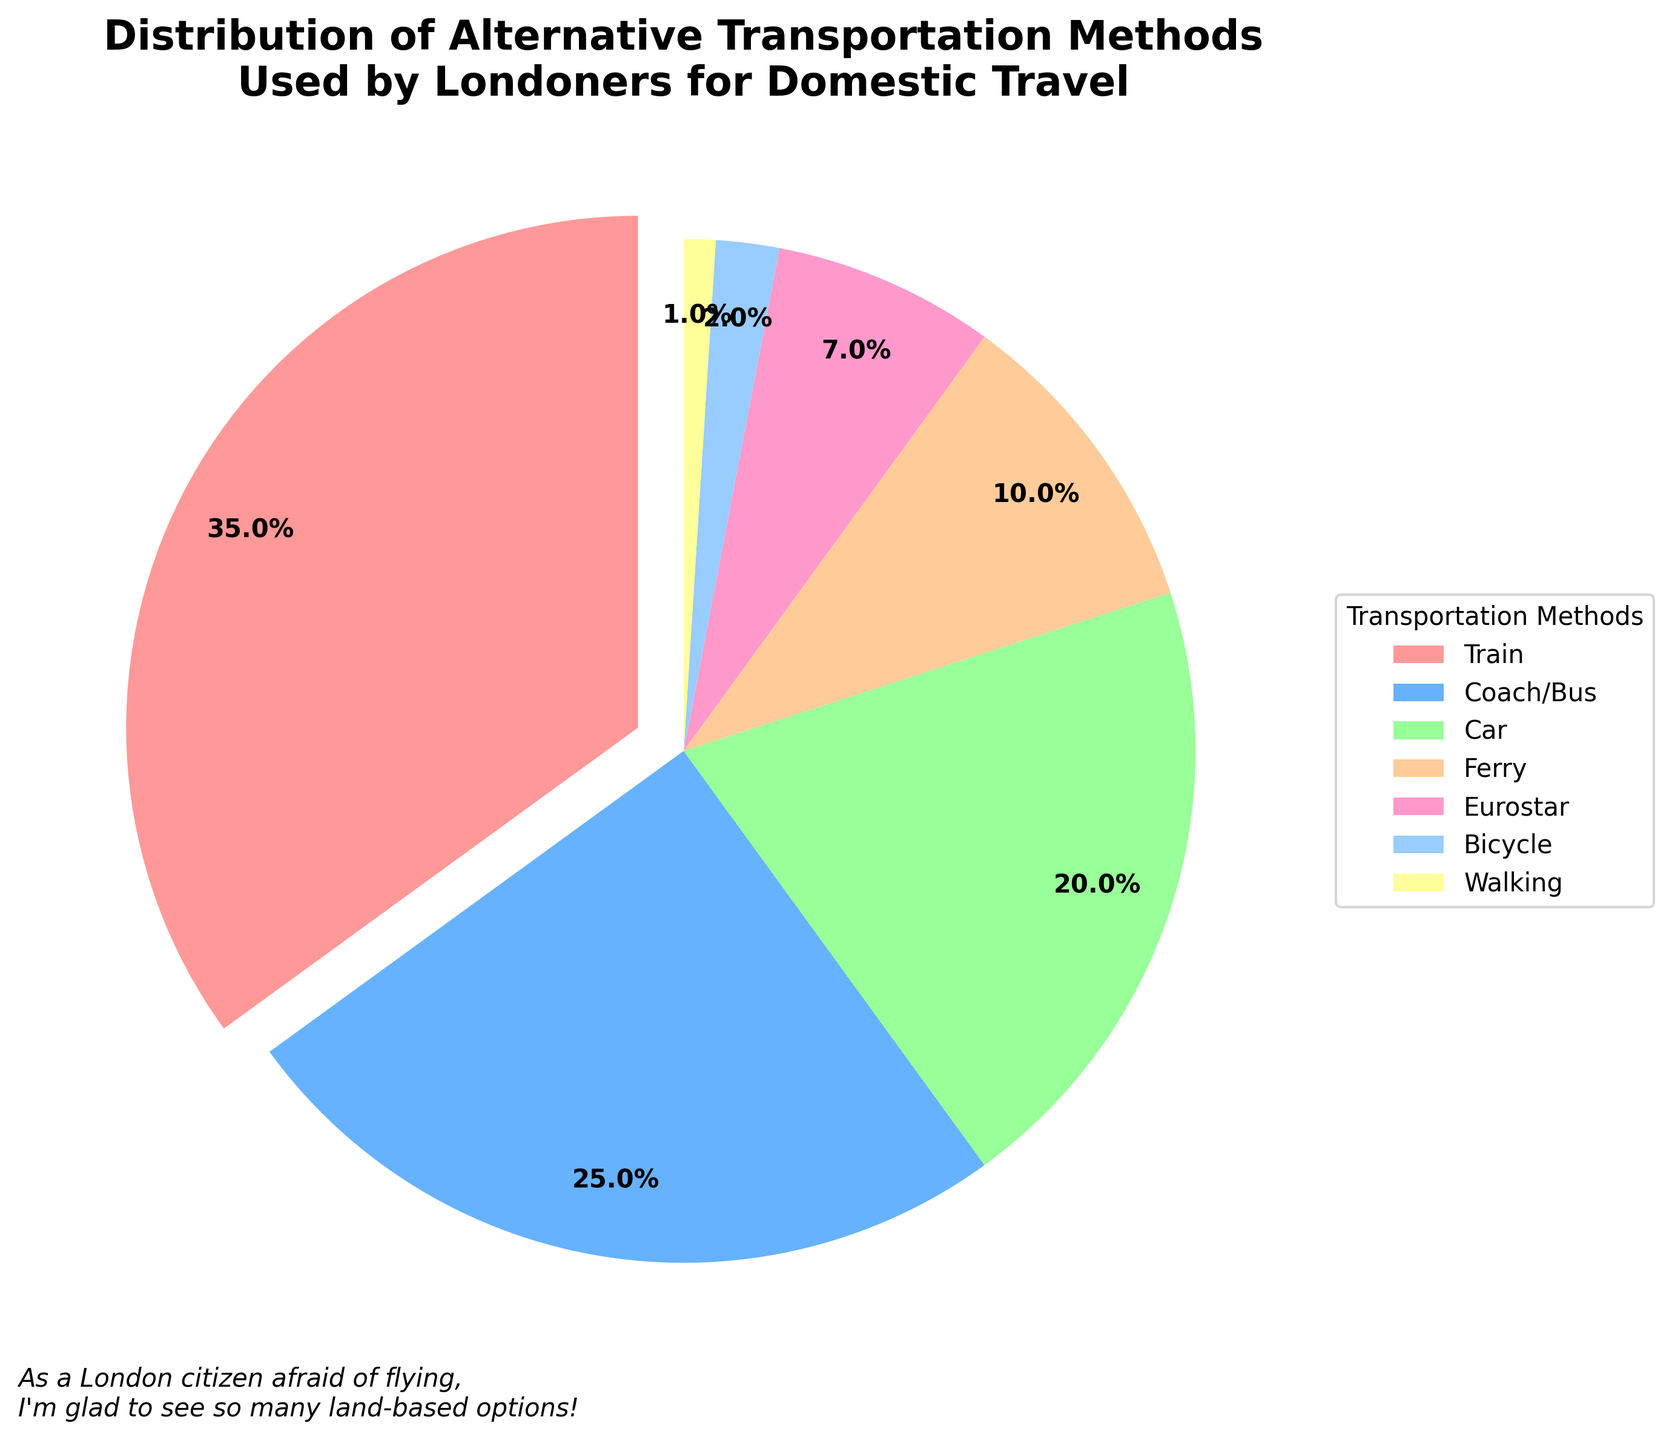Which transportation method is used the most by Londoners for domestic travel? To answer this, look at the pie chart to find the segment with the largest percentage. The largest segment is for the train, which represents 35% of the total.
Answer: Train What’s the sum of the percentages for Coach/Bus and Car? Add the percentages for Coach/Bus (25%) and Car (20%). 25% + 20% = 45%
Answer: 45% Which transportation method has the smallest percentage? Identify the segment with the smallest percentage in the pie chart. Walking has the smallest percentage at 1%.
Answer: Walking By how much does the percentage of Train users exceed the percentage of Ferry users? Subtract the percentage of Ferry users (10%) from the percentage of Train users (35%). 35% - 10% = 25%
Answer: 25% What is the total percentage of land-based transportation methods (Train, Coach/Bus, Car, Bicycle, Walking)? Sum the percentages for Train (35%), Coach/Bus (25%), Car (20%), Bicycle (2%), and Walking (1%). 35% + 25% + 20% + 2% + 1% = 83%
Answer: 83% Which two transportation methods have a combined percentage closest to the Eurostar percentage? To match the Eurostar percentage of 7%, sum different possible pairs of percentages. The closest pair is Bicycle (2%) and Walking (1%), with a combined total of 3%.
Answer: Bicycle and Walking How much more popular is the Coach/Bus option compared to the Eurostar option? Subtract the percentage of Eurostar users (7%) from the percentage of Coach/Bus users (25%). 25% - 7% = 18%
Answer: 18% What percentage of Londoners use either Ferry or Eurostar? Add the percentages for Ferry (10%) and Eurostar (7%). 10% + 7% = 17%
Answer: 17% Which color in the pie chart represents the Bicycle transportation method? Observe the colors in the pie chart legend to identify the one corresponding to Bicycle. The color for Bicycle is light blue.
Answer: Light blue 